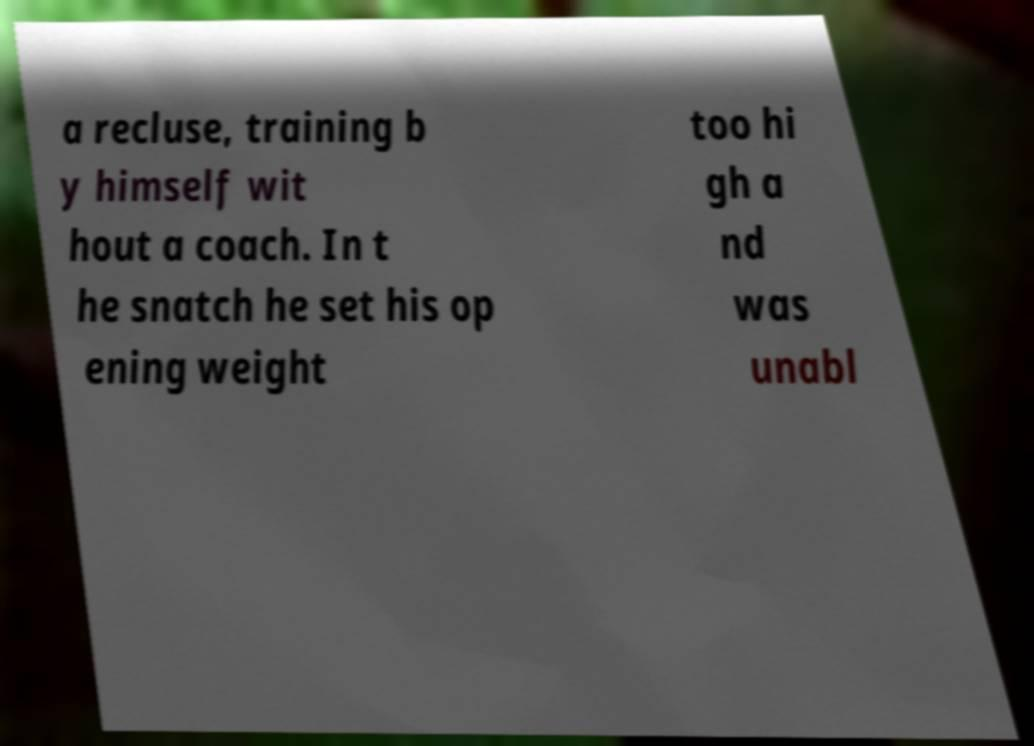I need the written content from this picture converted into text. Can you do that? a recluse, training b y himself wit hout a coach. In t he snatch he set his op ening weight too hi gh a nd was unabl 